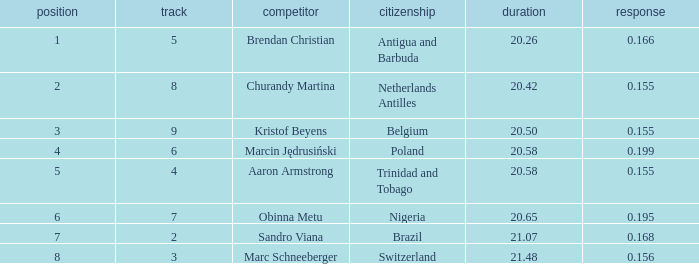Which Lane has a Time larger than 20.5, and a Nationality of trinidad and tobago? 4.0. 